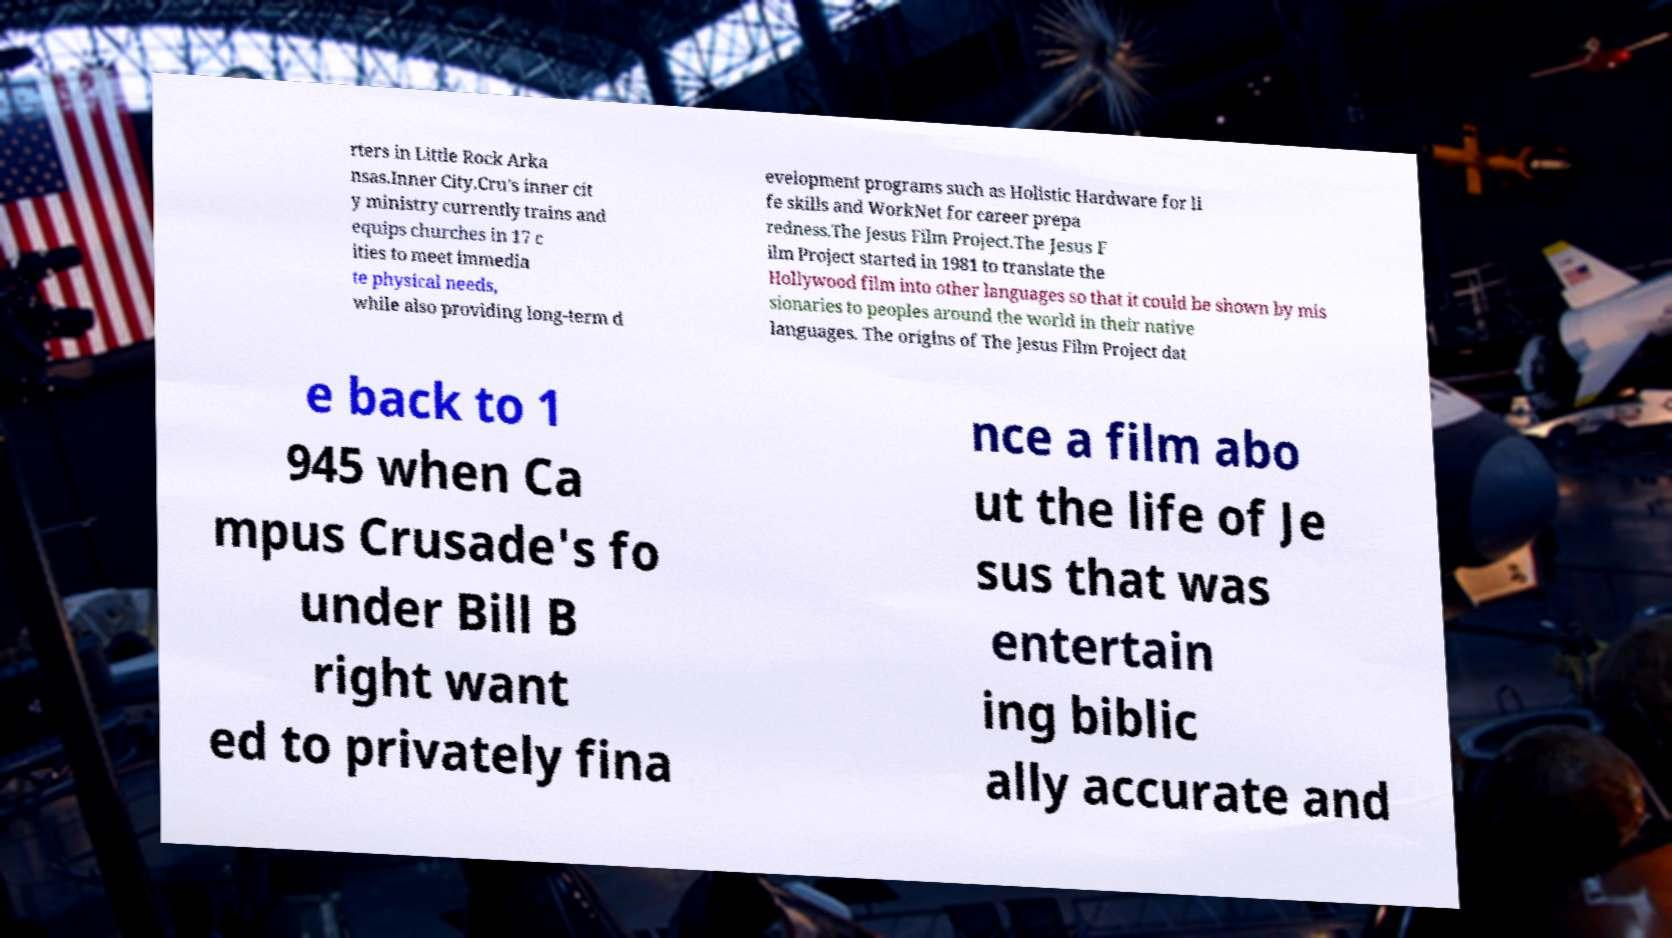There's text embedded in this image that I need extracted. Can you transcribe it verbatim? rters in Little Rock Arka nsas.Inner City.Cru's inner cit y ministry currently trains and equips churches in 17 c ities to meet immedia te physical needs, while also providing long-term d evelopment programs such as Holistic Hardware for li fe skills and WorkNet for career prepa redness.The Jesus Film Project.The Jesus F ilm Project started in 1981 to translate the Hollywood film into other languages so that it could be shown by mis sionaries to peoples around the world in their native languages. The origins of The Jesus Film Project dat e back to 1 945 when Ca mpus Crusade's fo under Bill B right want ed to privately fina nce a film abo ut the life of Je sus that was entertain ing biblic ally accurate and 